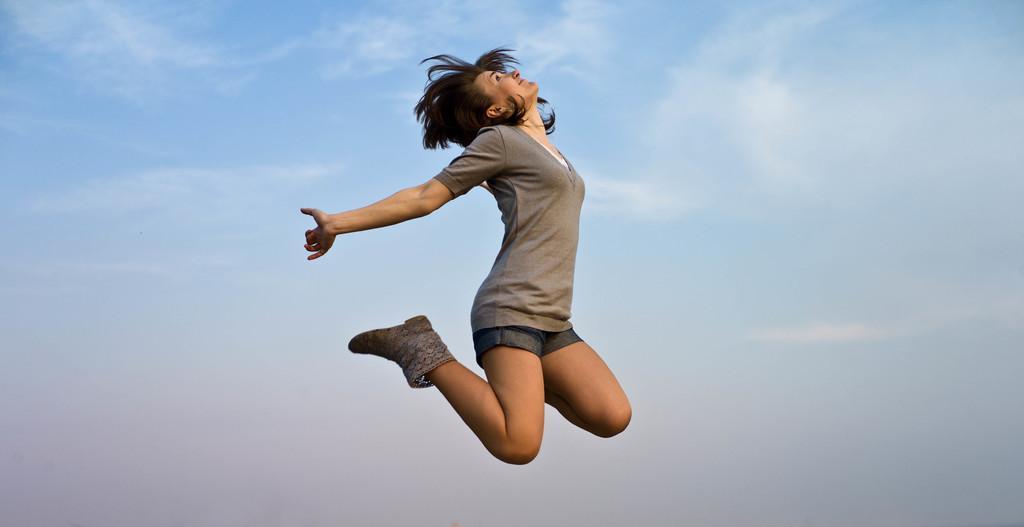Could you give a brief overview of what you see in this image? In this image I can see a woman is in the air. The woman is wearing a t-shirt, shorts and footwear. In the background I can see the sky. 